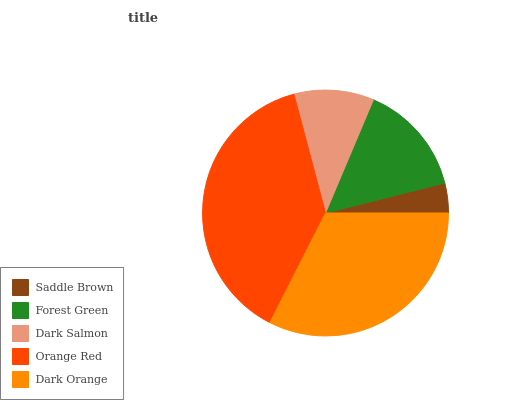Is Saddle Brown the minimum?
Answer yes or no. Yes. Is Orange Red the maximum?
Answer yes or no. Yes. Is Forest Green the minimum?
Answer yes or no. No. Is Forest Green the maximum?
Answer yes or no. No. Is Forest Green greater than Saddle Brown?
Answer yes or no. Yes. Is Saddle Brown less than Forest Green?
Answer yes or no. Yes. Is Saddle Brown greater than Forest Green?
Answer yes or no. No. Is Forest Green less than Saddle Brown?
Answer yes or no. No. Is Forest Green the high median?
Answer yes or no. Yes. Is Forest Green the low median?
Answer yes or no. Yes. Is Dark Salmon the high median?
Answer yes or no. No. Is Dark Salmon the low median?
Answer yes or no. No. 